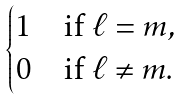Convert formula to latex. <formula><loc_0><loc_0><loc_500><loc_500>\begin{cases} 1 & \text {if $\ell=m$} , \\ 0 & \text {if $\ell\ne m$} . \end{cases}</formula> 